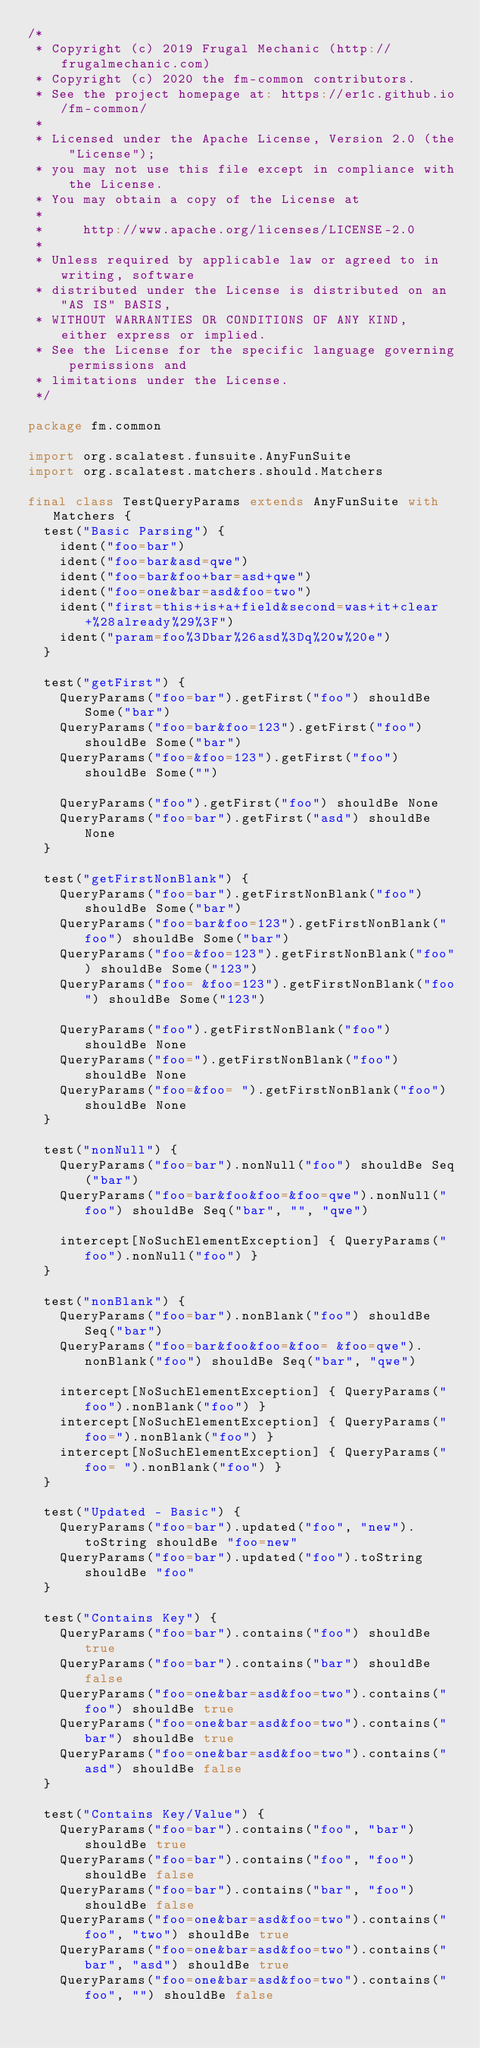Convert code to text. <code><loc_0><loc_0><loc_500><loc_500><_Scala_>/*
 * Copyright (c) 2019 Frugal Mechanic (http://frugalmechanic.com)
 * Copyright (c) 2020 the fm-common contributors.
 * See the project homepage at: https://er1c.github.io/fm-common/
 *
 * Licensed under the Apache License, Version 2.0 (the "License");
 * you may not use this file except in compliance with the License.
 * You may obtain a copy of the License at
 *
 *     http://www.apache.org/licenses/LICENSE-2.0
 *
 * Unless required by applicable law or agreed to in writing, software
 * distributed under the License is distributed on an "AS IS" BASIS,
 * WITHOUT WARRANTIES OR CONDITIONS OF ANY KIND, either express or implied.
 * See the License for the specific language governing permissions and
 * limitations under the License.
 */

package fm.common

import org.scalatest.funsuite.AnyFunSuite
import org.scalatest.matchers.should.Matchers

final class TestQueryParams extends AnyFunSuite with Matchers {
  test("Basic Parsing") {
    ident("foo=bar")
    ident("foo=bar&asd=qwe")
    ident("foo=bar&foo+bar=asd+qwe")
    ident("foo=one&bar=asd&foo=two")
    ident("first=this+is+a+field&second=was+it+clear+%28already%29%3F")
    ident("param=foo%3Dbar%26asd%3Dq%20w%20e")
  }

  test("getFirst") {
    QueryParams("foo=bar").getFirst("foo") shouldBe Some("bar")
    QueryParams("foo=bar&foo=123").getFirst("foo") shouldBe Some("bar")
    QueryParams("foo=&foo=123").getFirst("foo") shouldBe Some("")

    QueryParams("foo").getFirst("foo") shouldBe None
    QueryParams("foo=bar").getFirst("asd") shouldBe None
  }

  test("getFirstNonBlank") {
    QueryParams("foo=bar").getFirstNonBlank("foo") shouldBe Some("bar")
    QueryParams("foo=bar&foo=123").getFirstNonBlank("foo") shouldBe Some("bar")
    QueryParams("foo=&foo=123").getFirstNonBlank("foo") shouldBe Some("123")
    QueryParams("foo= &foo=123").getFirstNonBlank("foo") shouldBe Some("123")

    QueryParams("foo").getFirstNonBlank("foo") shouldBe None
    QueryParams("foo=").getFirstNonBlank("foo") shouldBe None
    QueryParams("foo=&foo= ").getFirstNonBlank("foo") shouldBe None
  }

  test("nonNull") {
    QueryParams("foo=bar").nonNull("foo") shouldBe Seq("bar")
    QueryParams("foo=bar&foo&foo=&foo=qwe").nonNull("foo") shouldBe Seq("bar", "", "qwe")

    intercept[NoSuchElementException] { QueryParams("foo").nonNull("foo") }
  }

  test("nonBlank") {
    QueryParams("foo=bar").nonBlank("foo") shouldBe Seq("bar")
    QueryParams("foo=bar&foo&foo=&foo= &foo=qwe").nonBlank("foo") shouldBe Seq("bar", "qwe")

    intercept[NoSuchElementException] { QueryParams("foo").nonBlank("foo") }
    intercept[NoSuchElementException] { QueryParams("foo=").nonBlank("foo") }
    intercept[NoSuchElementException] { QueryParams("foo= ").nonBlank("foo") }
  }

  test("Updated - Basic") {
    QueryParams("foo=bar").updated("foo", "new").toString shouldBe "foo=new"
    QueryParams("foo=bar").updated("foo").toString shouldBe "foo"
  }

  test("Contains Key") {
    QueryParams("foo=bar").contains("foo") shouldBe true
    QueryParams("foo=bar").contains("bar") shouldBe false
    QueryParams("foo=one&bar=asd&foo=two").contains("foo") shouldBe true
    QueryParams("foo=one&bar=asd&foo=two").contains("bar") shouldBe true
    QueryParams("foo=one&bar=asd&foo=two").contains("asd") shouldBe false
  }

  test("Contains Key/Value") {
    QueryParams("foo=bar").contains("foo", "bar") shouldBe true
    QueryParams("foo=bar").contains("foo", "foo") shouldBe false
    QueryParams("foo=bar").contains("bar", "foo") shouldBe false
    QueryParams("foo=one&bar=asd&foo=two").contains("foo", "two") shouldBe true
    QueryParams("foo=one&bar=asd&foo=two").contains("bar", "asd") shouldBe true
    QueryParams("foo=one&bar=asd&foo=two").contains("foo", "") shouldBe false</code> 